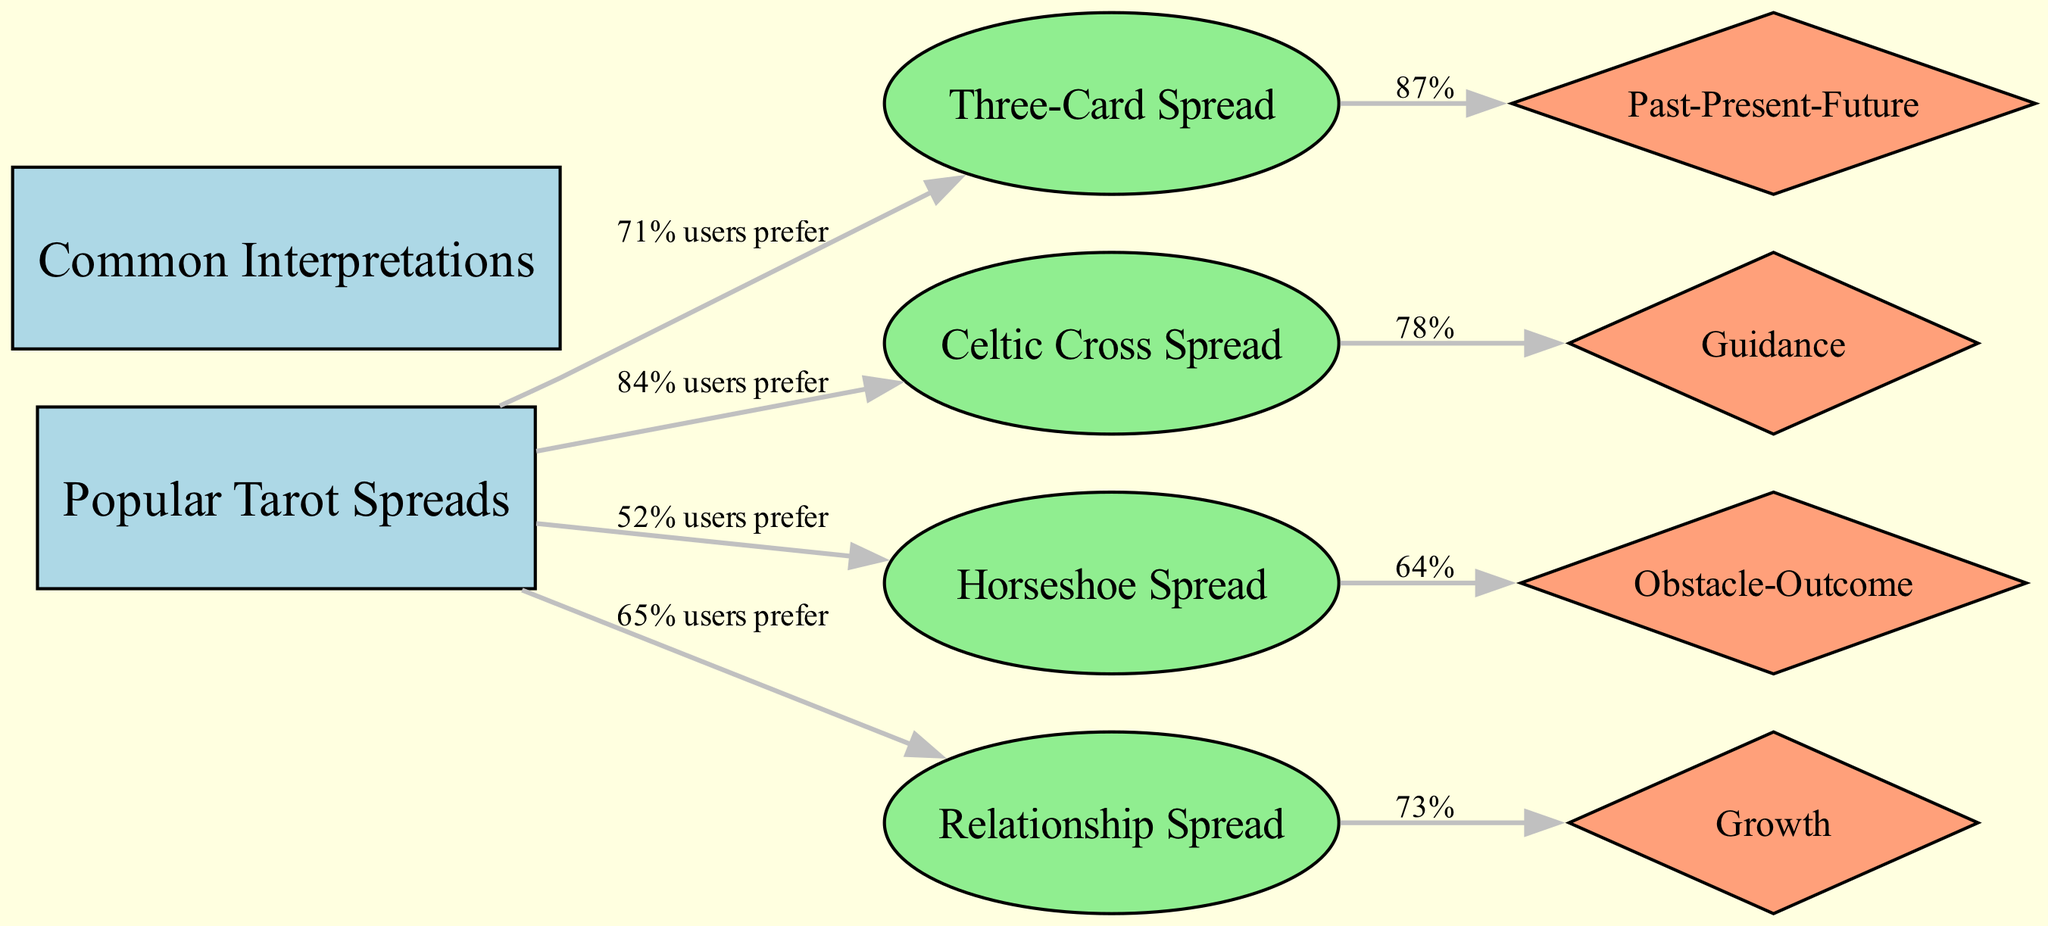What is the most preferred tarot spread according to the diagram? The diagram shows that the Celtic Cross Spread has 84% user preference, which is the highest among the listed spreads.
Answer: Celtic Cross Spread How many interpretations are listed in the diagram? There are four interpretations depicted in the diagram: Past-Present-Future, Guidance, Obstacle-Outcome, and Growth.
Answer: 4 What percentage of users prefer the Three-Card Spread? The diagram indicates that 71% of users prefer the Three-Card Spread.
Answer: 71% Which interpretation is most commonly associated with the Three-Card Spread? The diagram displays that 87% of users associate the Past-Present-Future interpretation with the Three-Card Spread.
Answer: Past-Present-Future Which tarot spread has the least user preference? The Horseshoe Spread has the least user preference at 52%, according to the diagram.
Answer: Horseshoe Spread What percentage of users prefer guidance with the Celtic Cross Spread? The diagram indicates that 78% of users prefer the Guidance interpretation with the Celtic Cross Spread.
Answer: 78% Which interpretation corresponds with the highest user preference of the Relationship Spread? The Relationship Spread has the Growth interpretation associated with it, preferred by 73% of users.
Answer: Growth What is the relationship between the Horseshoe Spread and its common interpretation? The diagram shows that 64% of users prefer the Obstacle-Outcome interpretation for the Horseshoe Spread.
Answer: Obstacle-Outcome How do the preferences for tarot spreads compare to each other based on user percentages? The percentages indicate that the Celtic Cross Spread (84%) is the most preferred, followed by the Relationship Spread (65%), then the Three-Card Spread (71%), and finally the Horseshoe Spread (52%).
Answer: Comparison of user percentages shows Celtic Cross Spread > Relationship Spread > Three-Card Spread > Horseshoe Spread 